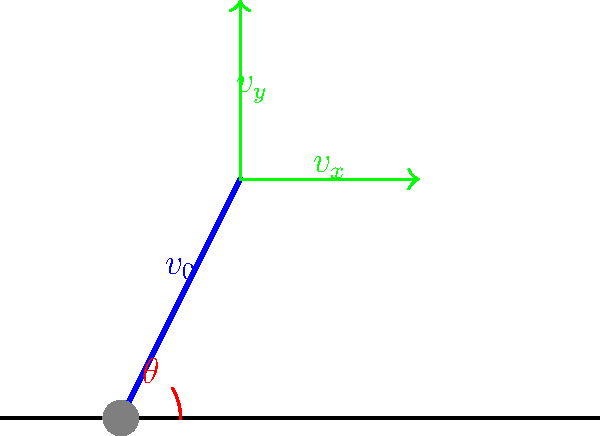As a dedicated fan of South Africa's women's hockey team, you're analyzing the optimal angle for a field hockey hit. Given that the initial velocity of the ball is 20 m/s and neglecting air resistance, at what angle $\theta$ should the player hit the ball to achieve the maximum range? To find the optimal angle for maximum range in projectile motion, we can follow these steps:

1) The range (R) of a projectile launched from ground level is given by the equation:

   $$R = \frac{v_0^2 \sin(2\theta)}{g}$$

   Where $v_0$ is the initial velocity, $\theta$ is the launch angle, and $g$ is the acceleration due to gravity (9.8 m/s²).

2) To maximize the range, we need to maximize $\sin(2\theta)$.

3) The maximum value of sine is 1, which occurs when its argument is 90°.

4) Therefore, for maximum range:

   $$2\theta = 90°$$
   $$\theta = 45°$$

5) This result is independent of the initial velocity, as long as air resistance is neglected.

6) In real-world scenarios, factors like air resistance and the unique dynamics of a hockey hit might slightly alter this ideal angle, but 45° remains a good approximation for maximum range.
Answer: 45° 